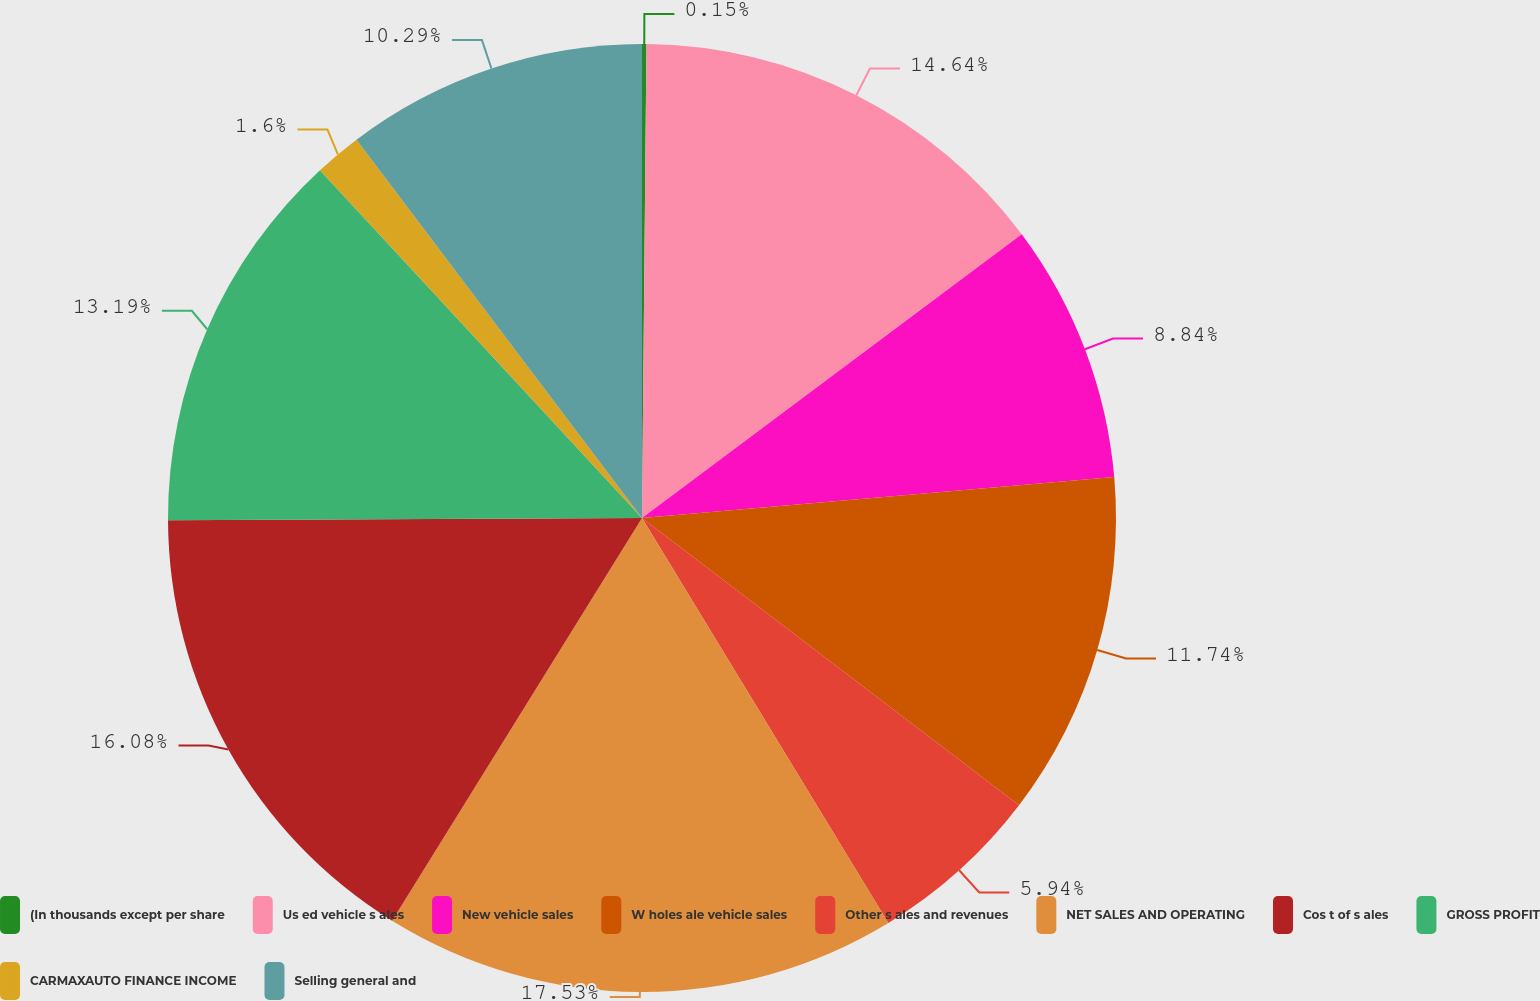Convert chart. <chart><loc_0><loc_0><loc_500><loc_500><pie_chart><fcel>(In thousands except per share<fcel>Us ed vehicle s ales<fcel>New vehicle sales<fcel>W holes ale vehicle sales<fcel>Other s ales and revenues<fcel>NET SALES AND OPERATING<fcel>Cos t of s ales<fcel>GROSS PROFIT<fcel>CARMAXAUTO FINANCE INCOME<fcel>Selling general and<nl><fcel>0.15%<fcel>14.64%<fcel>8.84%<fcel>11.74%<fcel>5.94%<fcel>17.54%<fcel>16.09%<fcel>13.19%<fcel>1.6%<fcel>10.29%<nl></chart> 